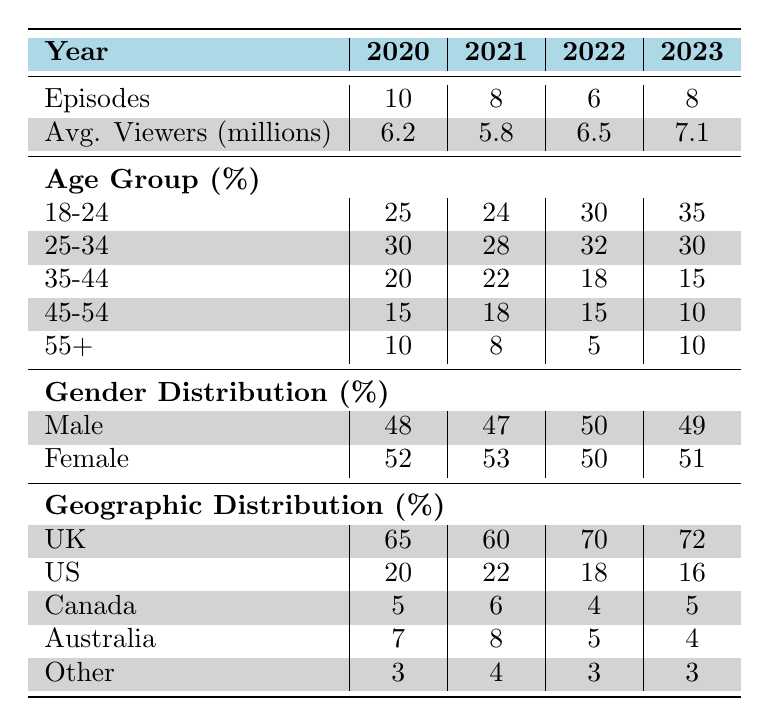What was the average number of viewers for Doctor Who in 2022? The average number of viewers in 2022, as stated in the table, is 6.5 million.
Answer: 6.5 million Which year had the highest percentage of viewers aged 18-24? The table indicates that 2023 had 35% of viewers aged 18-24, which is the highest percentage among the years listed.
Answer: 2023 Did the number of episodes decrease from 2020 to 2021? The table shows that 2020 had 10 episodes and 2021 had 8 episodes, indicating a decrease.
Answer: Yes What is the difference in average viewers between 2020 and 2023? In 2020 the average viewers were 6.2 million and in 2023 they were 7.1 million. The difference is 7.1 - 6.2 = 0.9 million.
Answer: 0.9 million Was the gender distribution among viewers consistent over the years? The gender distribution varied slightly but was mostly close. For example, in 2020 it was 48% male and 52% female, while in 2022 it was exactly 50% each, indicating overall consistency with minor fluctuations.
Answer: Yes In which year did the US viewers percentage drop below 20%? Looking at the table, the US viewers were 20% in 2020, 22% in 2021, and then dropped to 18% in 2022. Therefore, 2022 is the first year where the percentage went below 20%.
Answer: 2022 What was the average percentage of viewers aged 45-54 from 2020 to 2023? To find the average percentage of viewers aged 45-54, we add the percentages for each year (15 + 18 + 15 + 10) = 58 and divide by 4 (the number of years): 58 / 4 = 14.5%.
Answer: 14.5% Which year had the lowest average viewers, and how many were there? The table shows that 2021 had the lowest average viewers at 5.8 million.
Answer: 2021, 5.8 million Did the percentage of viewers in Canada significantly change from 2020 to 2023? By comparing the percentages, we can see that Canada had 5% in 2020, 6% in 2021, 4% in 2022, and returned to 5% in 2023, showing slight fluctuations but not a significant change overall.
Answer: No 